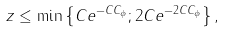Convert formula to latex. <formula><loc_0><loc_0><loc_500><loc_500>z \leq \min \left \{ C e ^ { - C C _ { \phi } } ; 2 C e ^ { - 2 C C _ { \phi } } \right \} ,</formula> 